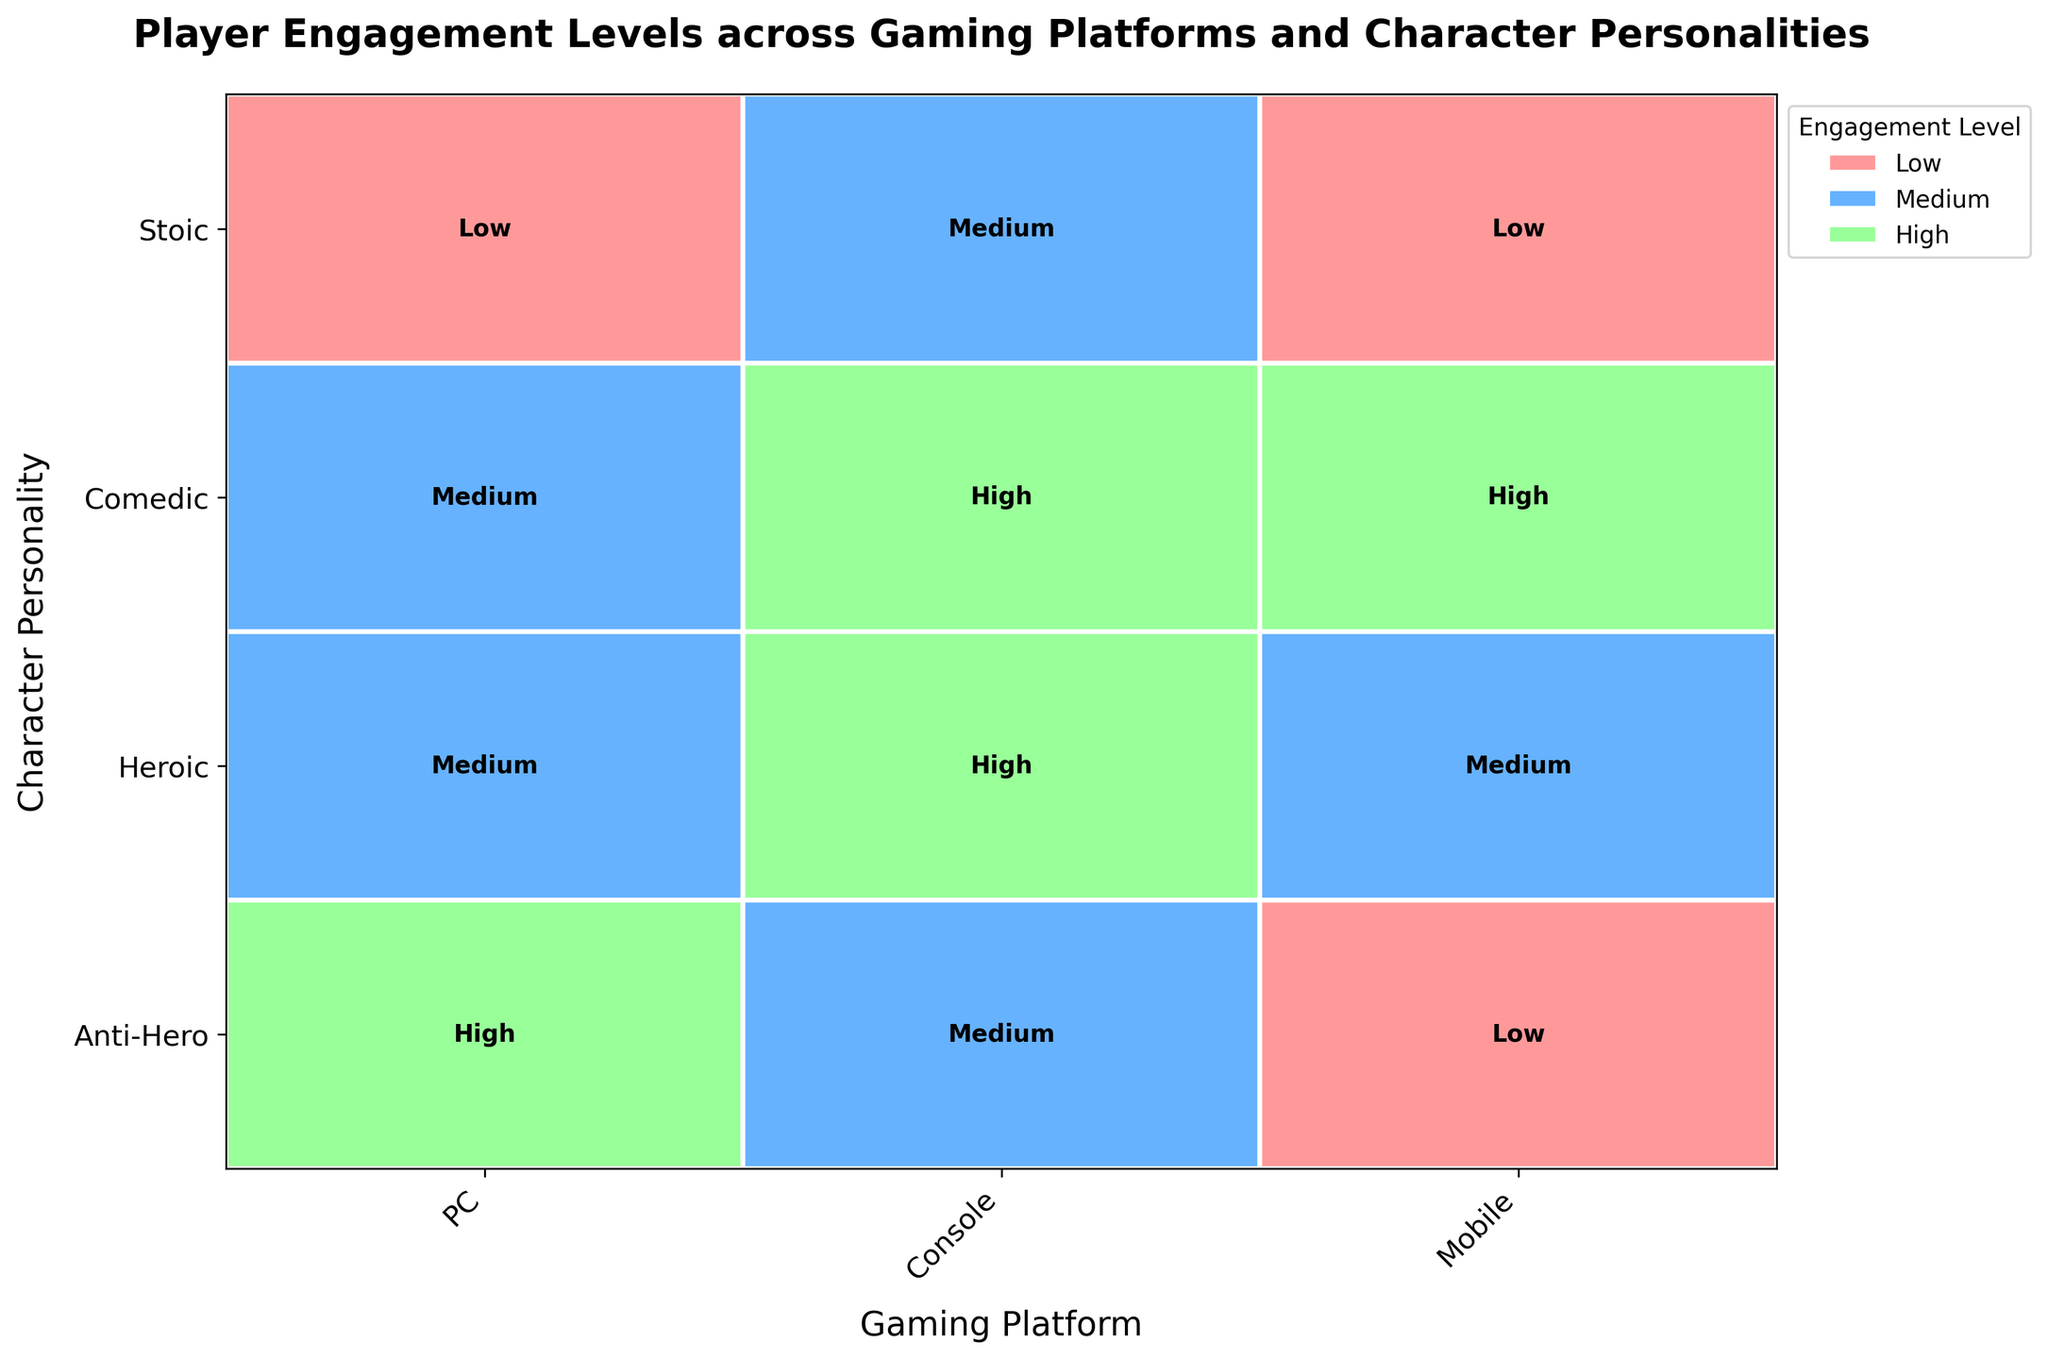What are the gaming platforms displayed on the x-axis? The x-axis labels are the unique gaming platforms identified in the data. These platforms are indicated as 'PC', 'Console', and 'Mobile', which are marked accordingly on the x-axis.
Answer: PC, Console, Mobile Which character personality has the highest engagement level on the Console platform? To find the highest engagement level for the Console platform, locate the 'Console' column, then identify the box with the label 'High'. This corresponds to the 'Heroic' and 'Comedic' character personalities.
Answer: Heroic, Comedic How many characters have low engagement levels on the Mobile platform? Examine the 'Mobile' column and count the boxes labeled 'Low'. There are two character personalities, 'Anti-Hero' and 'Stoic', in the Mobile platform with low engagement levels.
Answer: 2 Which gaming platform has the most high engagement levels? Review the plot to see which column has the most 'High' labels. The 'Console' platform column has two high engagement levels, more than any other platform.
Answer: Console Compare the engagement levels of 'Anti-Hero' character across the different platforms. Look at the row for 'Anti-Hero' across all three columns. The engagement levels are 'High' for PC, 'Medium' for Console, and 'Low' for Mobile.
Answer: High (PC), Medium (Console), Low (Mobile) What color represents the 'High' engagement level in the plot? Each engagement level has a distinct color, with 'High' engagement levels shown in a specific color. The box labeled 'High' is filled with a green color.
Answer: Green How many medium engagement levels are observed across all platforms? Count all the boxes labeled 'Medium' across the entire plot. There are four such boxes: PC (Heroic, Comedic), Console (Anti-Hero, Stoic), and Mobile (Heroic).
Answer: 4 Which character personalities have the same engagement level across all three platforms? Check each row to see if the engagement levels match for all three platforms. No character personality has the same engagement level across all three platforms.
Answer: None What is the engagement level of 'Stoic' characters on the PC platform? Identify the 'Stoic' row and follow it to the 'PC' column. The engagement level there is labeled 'Low'.
Answer: Low Which platform has the lowest number of low engagement levels? Count the number of 'Low' labels in each column. The 'Console' platform has no low engagement levels, which is the least.
Answer: Console 